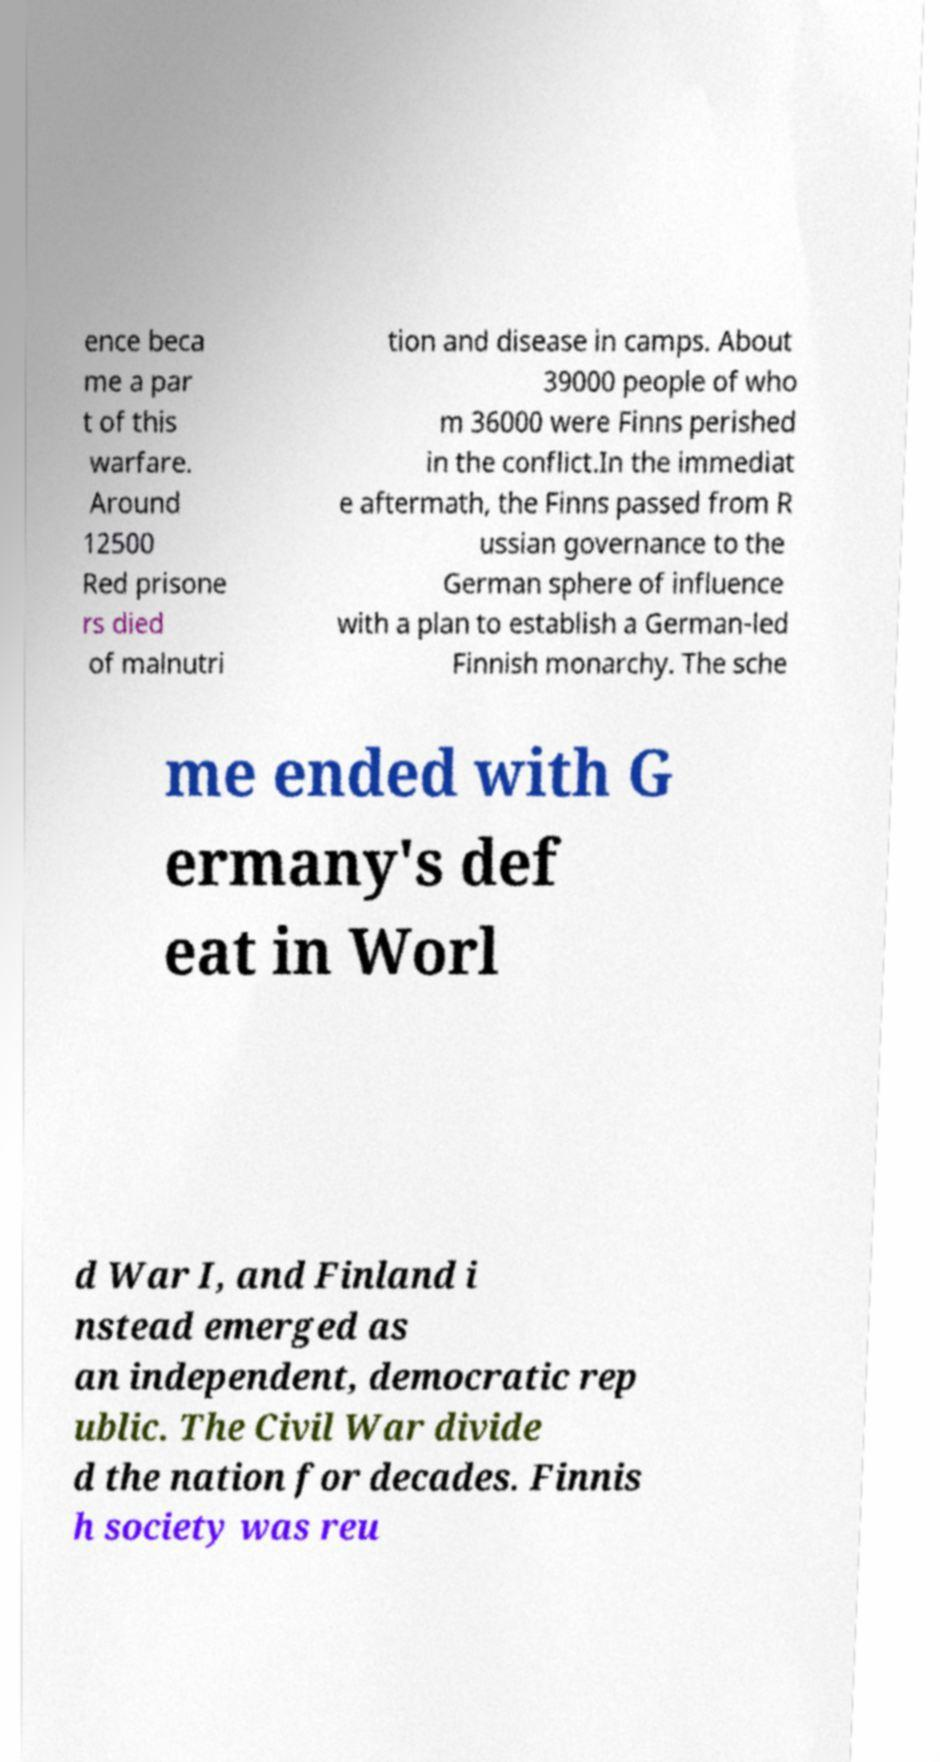Could you assist in decoding the text presented in this image and type it out clearly? ence beca me a par t of this warfare. Around 12500 Red prisone rs died of malnutri tion and disease in camps. About 39000 people of who m 36000 were Finns perished in the conflict.In the immediat e aftermath, the Finns passed from R ussian governance to the German sphere of influence with a plan to establish a German-led Finnish monarchy. The sche me ended with G ermany's def eat in Worl d War I, and Finland i nstead emerged as an independent, democratic rep ublic. The Civil War divide d the nation for decades. Finnis h society was reu 